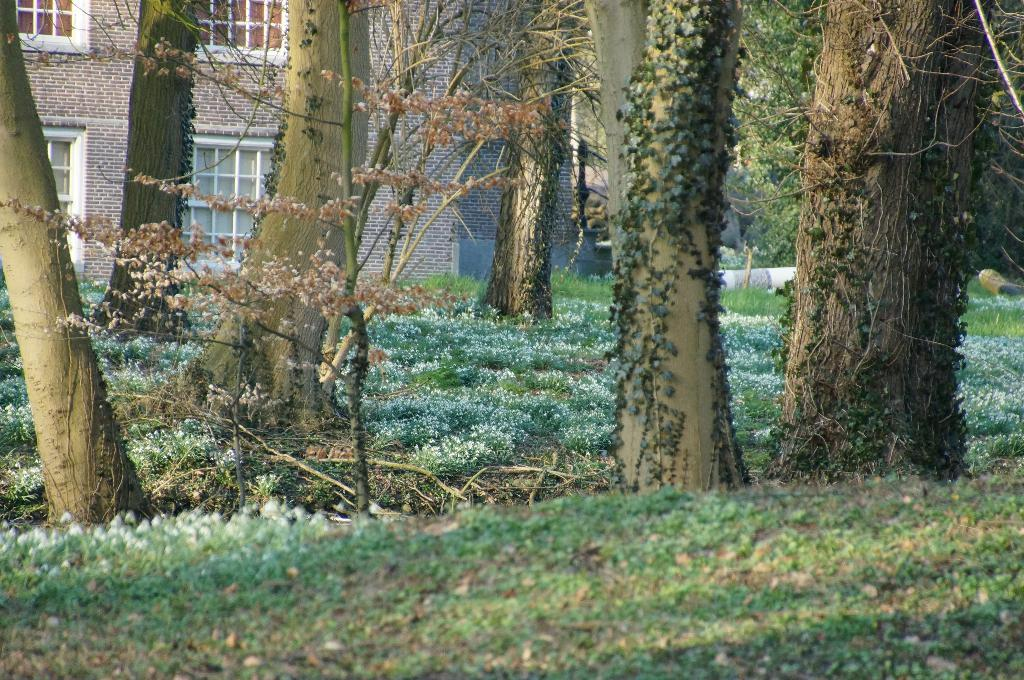What type of natural elements can be seen in the image? There are tree trunks, plants, and trees in the image. What type of man-made structure is present in the image? There is a building in the image. Can you describe any additional features near the building? There is a pole on the right side of the building. What type of honey can be seen dripping from the tree trunks in the image? There is no honey present in the image; it features tree trunks, plants, trees, a building, and a pole. 